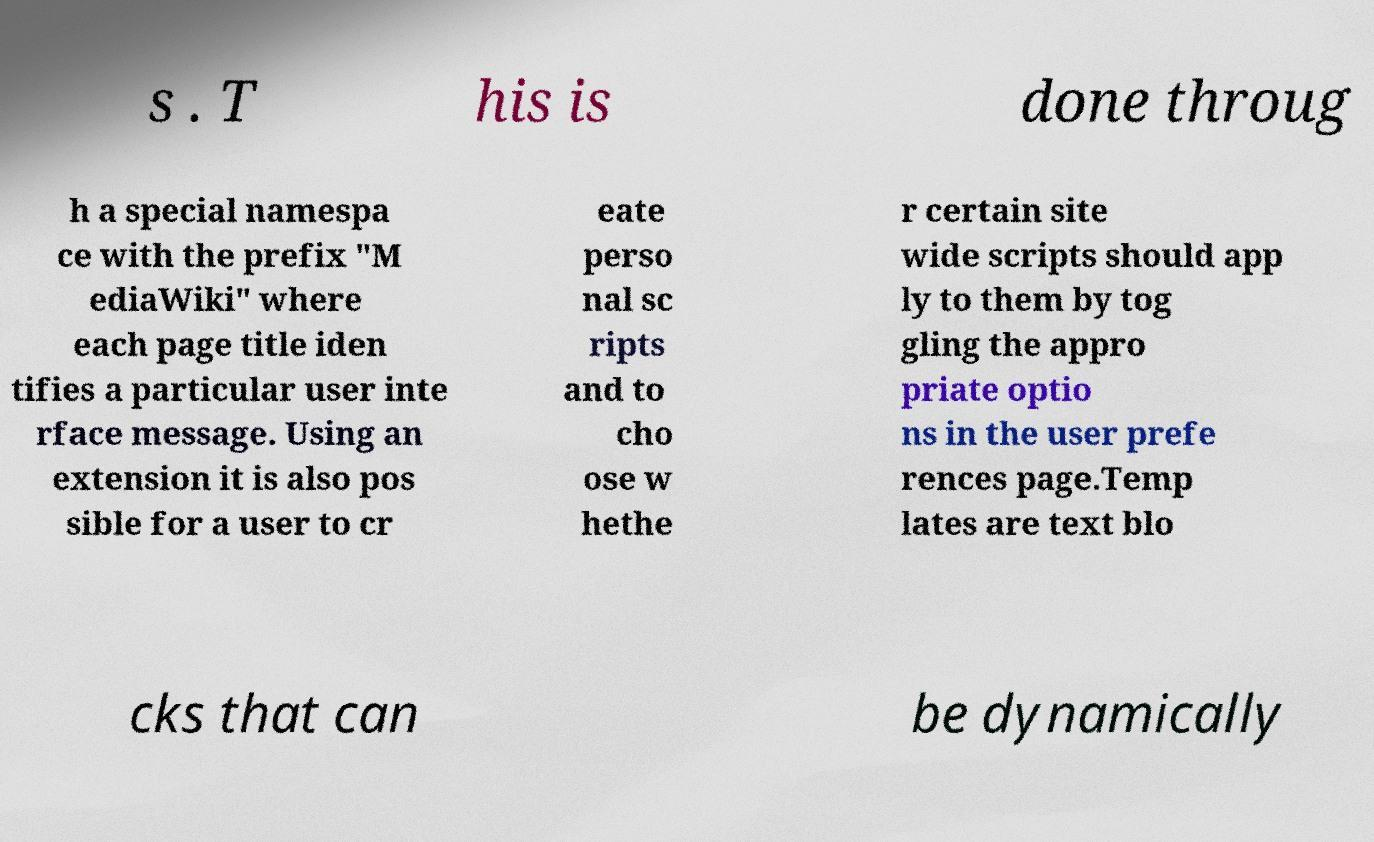Please read and relay the text visible in this image. What does it say? s . T his is done throug h a special namespa ce with the prefix "M ediaWiki" where each page title iden tifies a particular user inte rface message. Using an extension it is also pos sible for a user to cr eate perso nal sc ripts and to cho ose w hethe r certain site wide scripts should app ly to them by tog gling the appro priate optio ns in the user prefe rences page.Temp lates are text blo cks that can be dynamically 